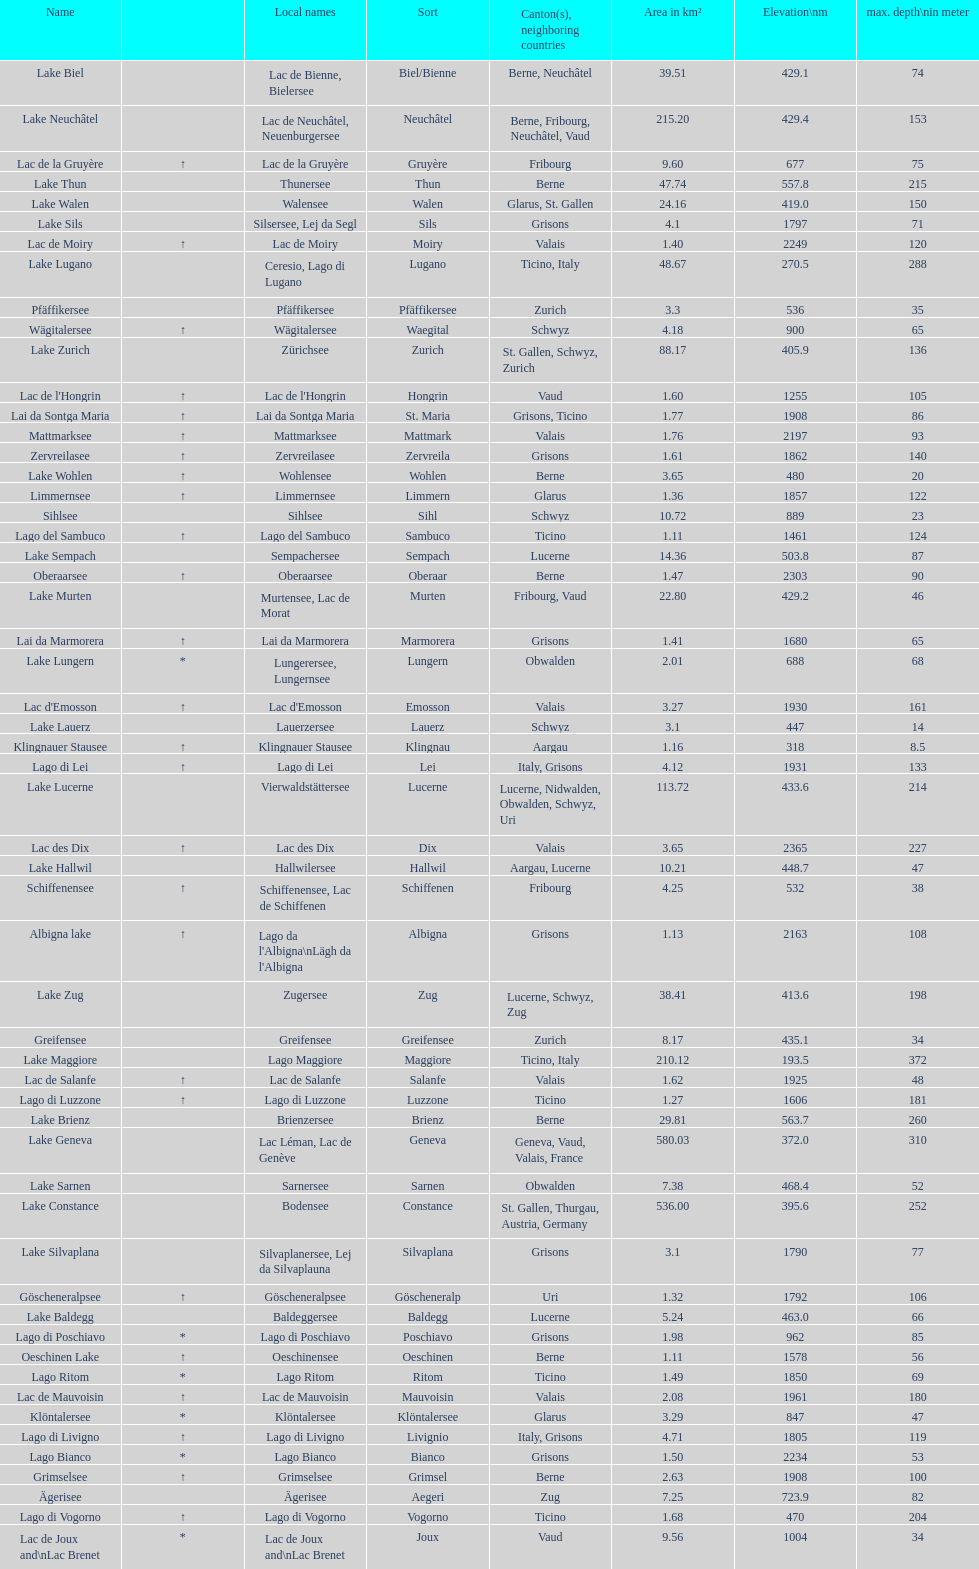What is the deepest lake? Lake Maggiore. 